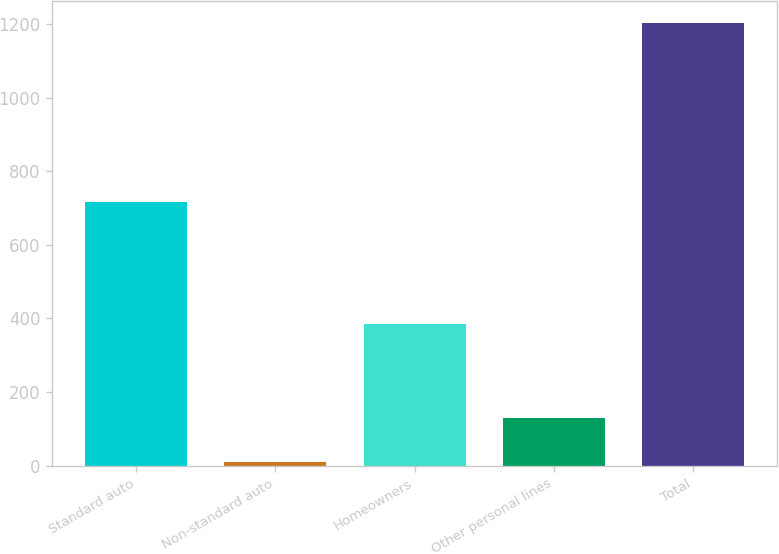<chart> <loc_0><loc_0><loc_500><loc_500><bar_chart><fcel>Standard auto<fcel>Non-standard auto<fcel>Homeowners<fcel>Other personal lines<fcel>Total<nl><fcel>716<fcel>9<fcel>385<fcel>128.5<fcel>1204<nl></chart> 